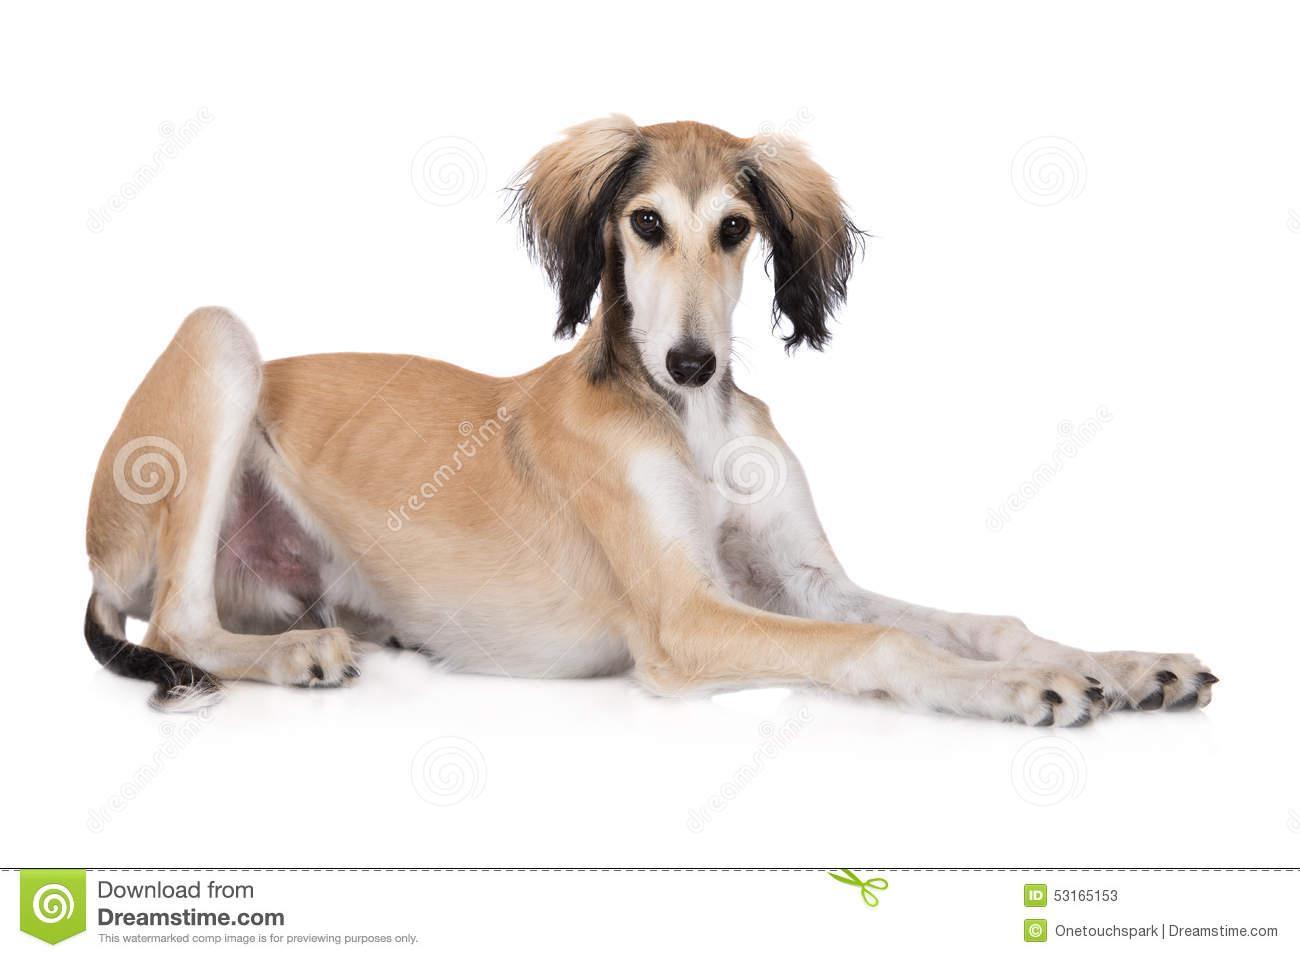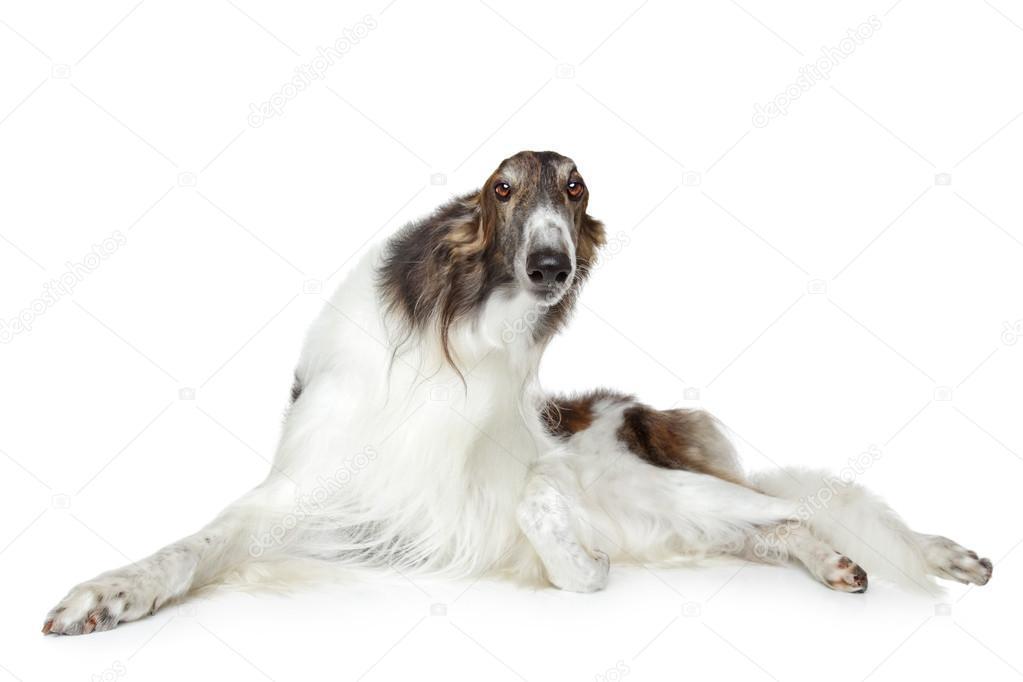The first image is the image on the left, the second image is the image on the right. For the images shown, is this caption "The dog in the image on the left is lying down." true? Answer yes or no. Yes. The first image is the image on the left, the second image is the image on the right. Analyze the images presented: Is the assertion "Both of the dogs are in similar body positions and with similar backgrounds." valid? Answer yes or no. Yes. 